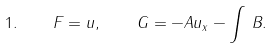<formula> <loc_0><loc_0><loc_500><loc_500>1 . \quad F = u , \quad G = - A u _ { x } - \int \, B .</formula> 